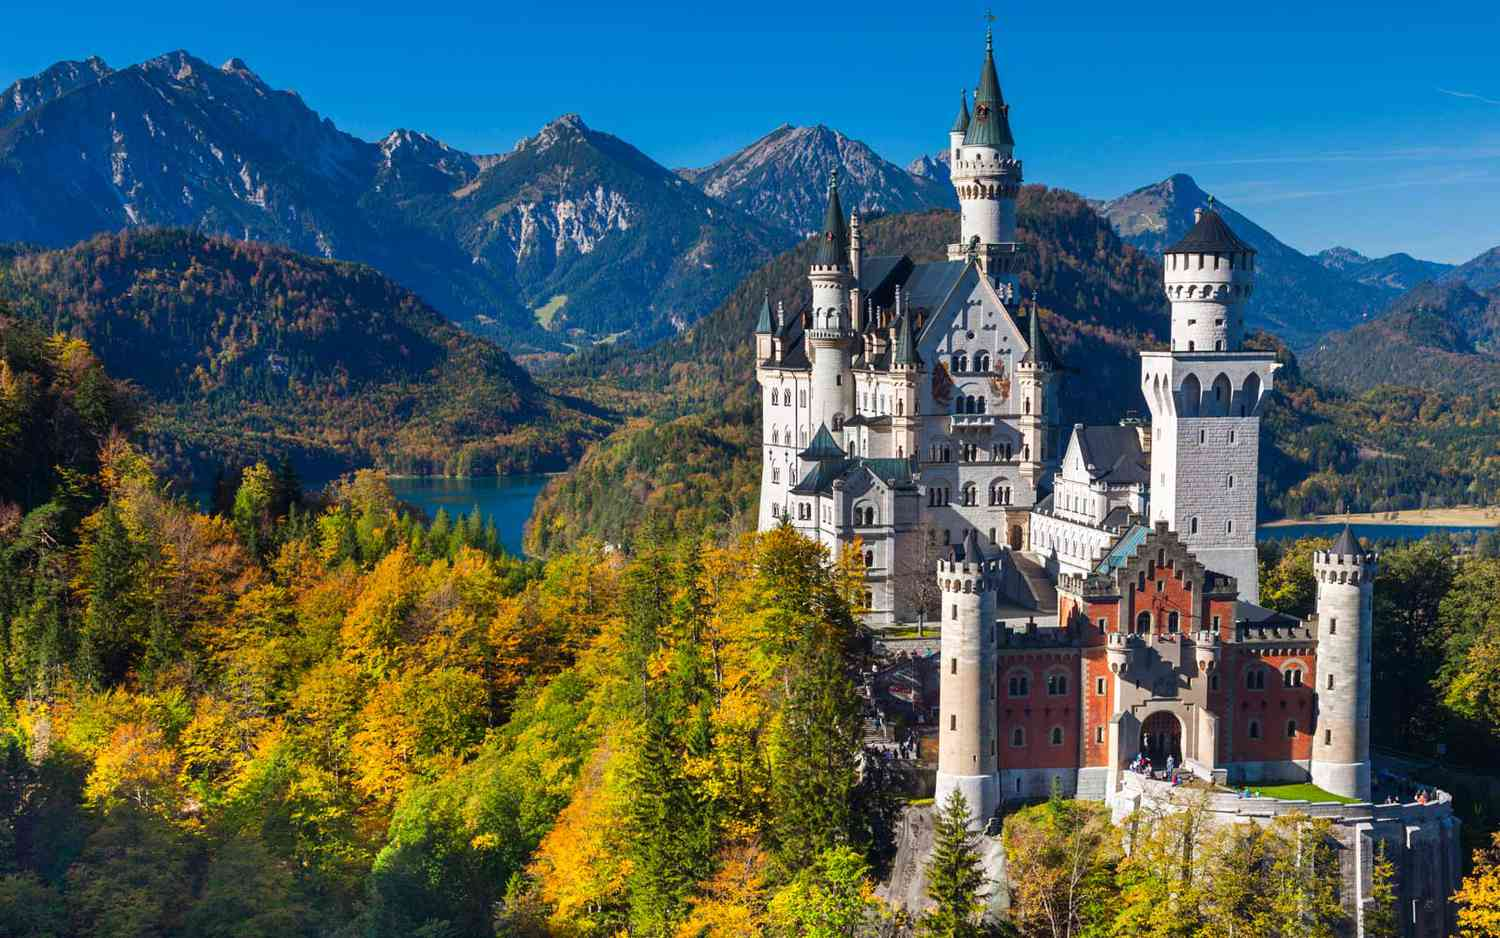Imagine a magical event happening at Neuschwanstein Castle. Describe it. As the first snowflakes of winter gently descend upon Neuschwanstein Castle, the scene transforms into a winter wonderland. Suddenly, the castle's towers are illuminated with a soft glow, and a symphony of lights dances across its façade, synchronized to a melody that seems to emanate from the very walls themselves. At the stroke of midnight, as the moonlight bathes the scene in a silvery hue, the drawbridge lowers to reveal an ethereal procession of mythical creatures. Elves, fairies, and unicorns emerge, their presence orchestrating an enchanting ballet on the castle grounds. The air is filled with the aroma of spiced cider and the laughter of children, as if the very spirit of the castle comes alive to celebrate in timeless fairy-tale fashion. It is a magical event that captivates the hearts of all who are fortunate enough to witness it, leaving an indelible mark on their imaginations. What are some interesting facts about Neuschwanstein Castle? Neuschwanstein Castle holds many fascinating facts within its walls. Here are a few:
1. **The Disney Connection:** Neuschwanstein Castle famously inspired Walt Disney's design of Sleeping Beauty's castle in Disneyland.
2. **Unfinished Beauty:** Despite its grandeur, only about 14 out of the 200 planned rooms were completed by the time of King Ludwig II's death.
3. **Innovative Design:** The castle featured advanced technologies for its time, including central heating, running water, and even a 'telephone' system for internal communication.
4. **Hidden Chapel:** The Throne Hall, a notable room, was designed to have a grand throne that doubled as a chapel, but the throne was never completed.
5. **Visitor Magnet:** Today, Neuschwanstein Castle attracts over 1.4 million visitors annually, making it one of the most popular tourist destinations in Europe. How would the landscape around Neuschwanstein Castle change with the seasons? The landscape around Neuschwanstein Castle undergoes breathtaking transformations with each passing season. In spring, the surrounding forests burst into life with vibrant green foliage and blooming wildflowers, creating a picture-perfect contrast to the castle’s pristine white walls. Summer offers a lush, verdant backdrop, with dense canopies providing a lush setting for visitors to explore the castle grounds under the warm sun. Come autumn, the landscape is set ablaze with shades of gold, orange, and red as the leaves change color, adding a magical warmth to the view. Winter transforms the castle into a serene, snow-covered paradise, where the stark white landscape enhances the fairy-tale charm of the castle. Each season offers a unique perspective and beauty, making Neuschwanstein a year-round marvel. 